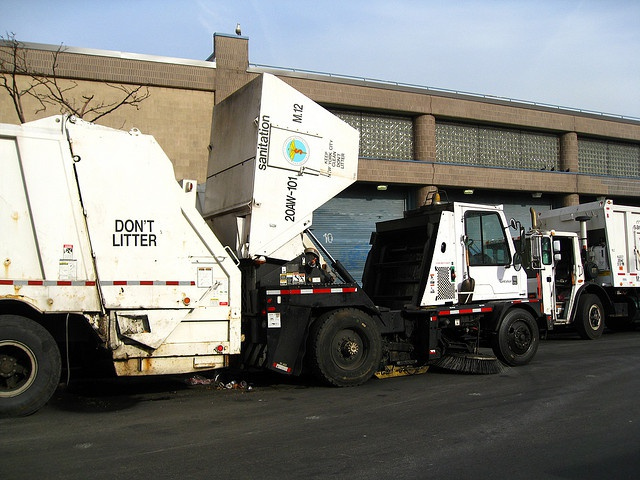Describe the objects in this image and their specific colors. I can see truck in darkgray, ivory, black, and gray tones and truck in darkgray, black, ivory, and gray tones in this image. 